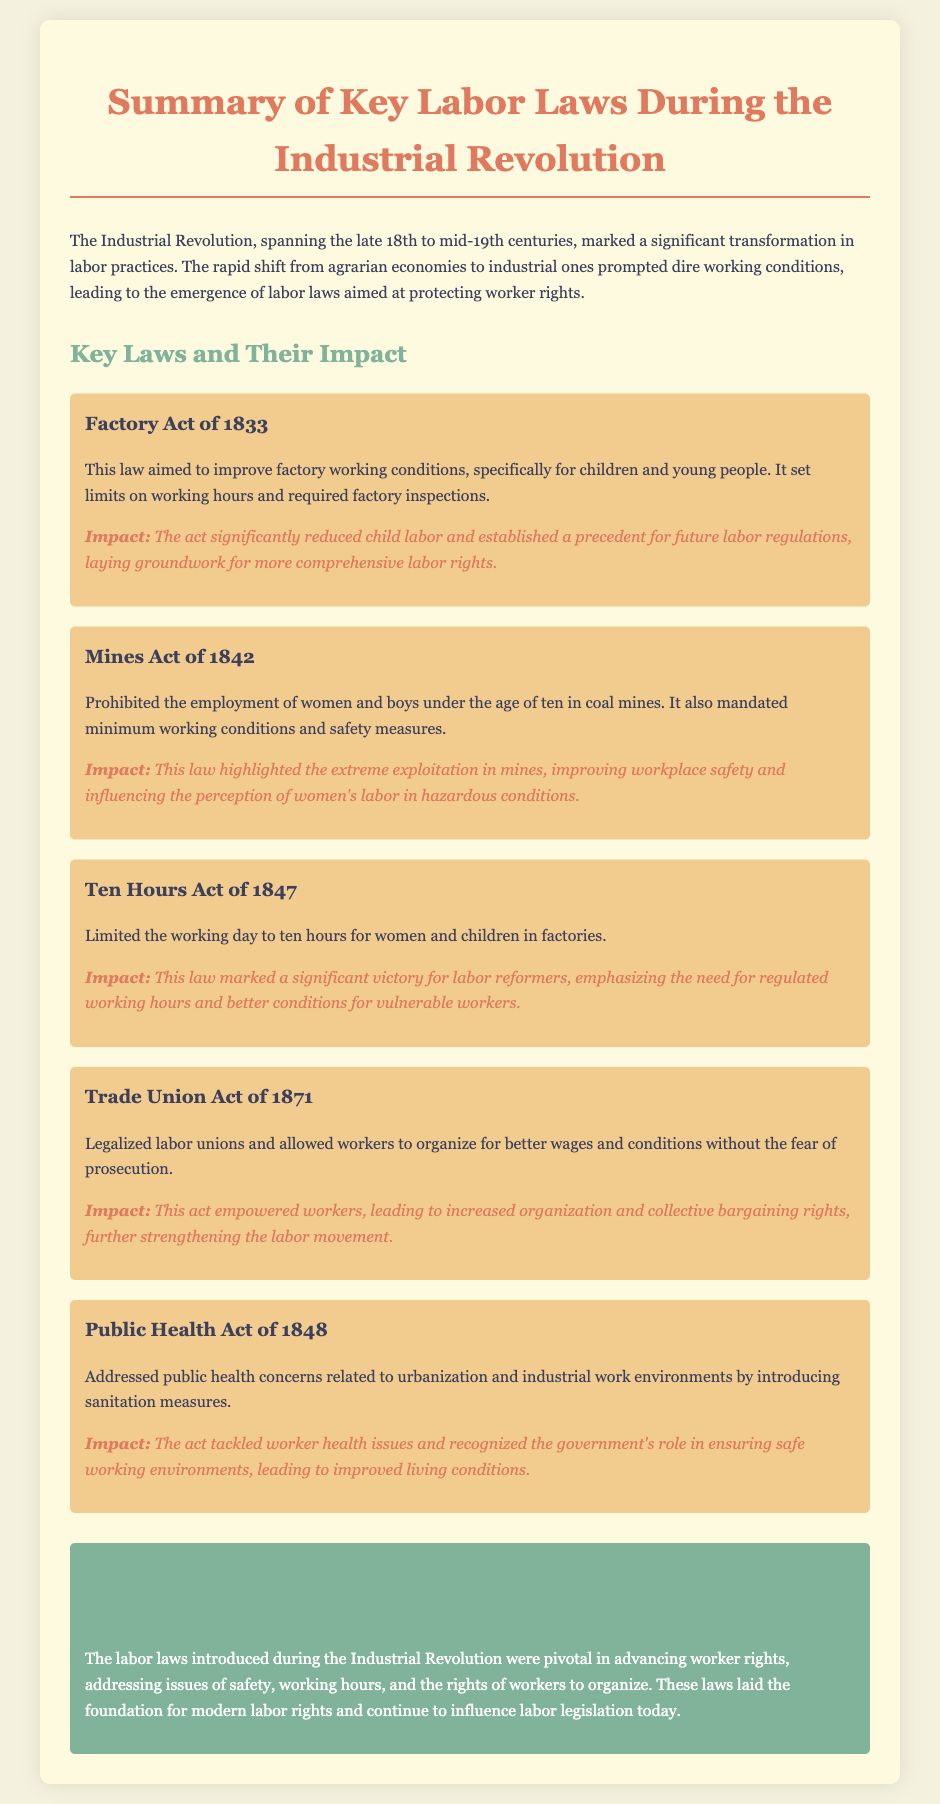What is the Factory Act of 1833? The document defines the Factory Act of 1833 as a law that aimed to improve factory working conditions, specifically for children and young people, by setting limits on working hours and requiring factory inspections.
Answer: Factory Act of 1833 What was prohibited by the Mines Act of 1842? The Mines Act of 1842 prohibited the employment of women and boys under the age of ten in coal mines.
Answer: Employment of women and boys under the age of ten What did the Ten Hours Act of 1847 limit? The Ten Hours Act of 1847 limited the working day to ten hours for women and children in factories.
Answer: Working day to ten hours What year was the Trade Union Act passed? The Trade Union Act was passed in 1871.
Answer: 1871 What is one major impact of the Public Health Act of 1848? One major impact of the Public Health Act of 1848 is that it tackled worker health issues and recognized the government's role in ensuring safe working environments.
Answer: Tackled worker health issues What significant victory did the Ten Hours Act of 1847 represent? The document describes the Ten Hours Act of 1847 as a significant victory for labor reformers, emphasizing the need for regulated working hours.
Answer: Significant victory for labor reformers What role did the Trade Union Act of 1871 have in worker rights? The Trade Union Act of 1871 legalized labor unions and allowed workers to organize for better wages and conditions without the fear of prosecution.
Answer: Legalized labor unions How did labor laws during the Industrial Revolution affect modern labor rights? The laws introduced during the Industrial Revolution were pivotal in advancing worker rights and continue to influence labor legislation today.
Answer: Influenced modern labor rights 